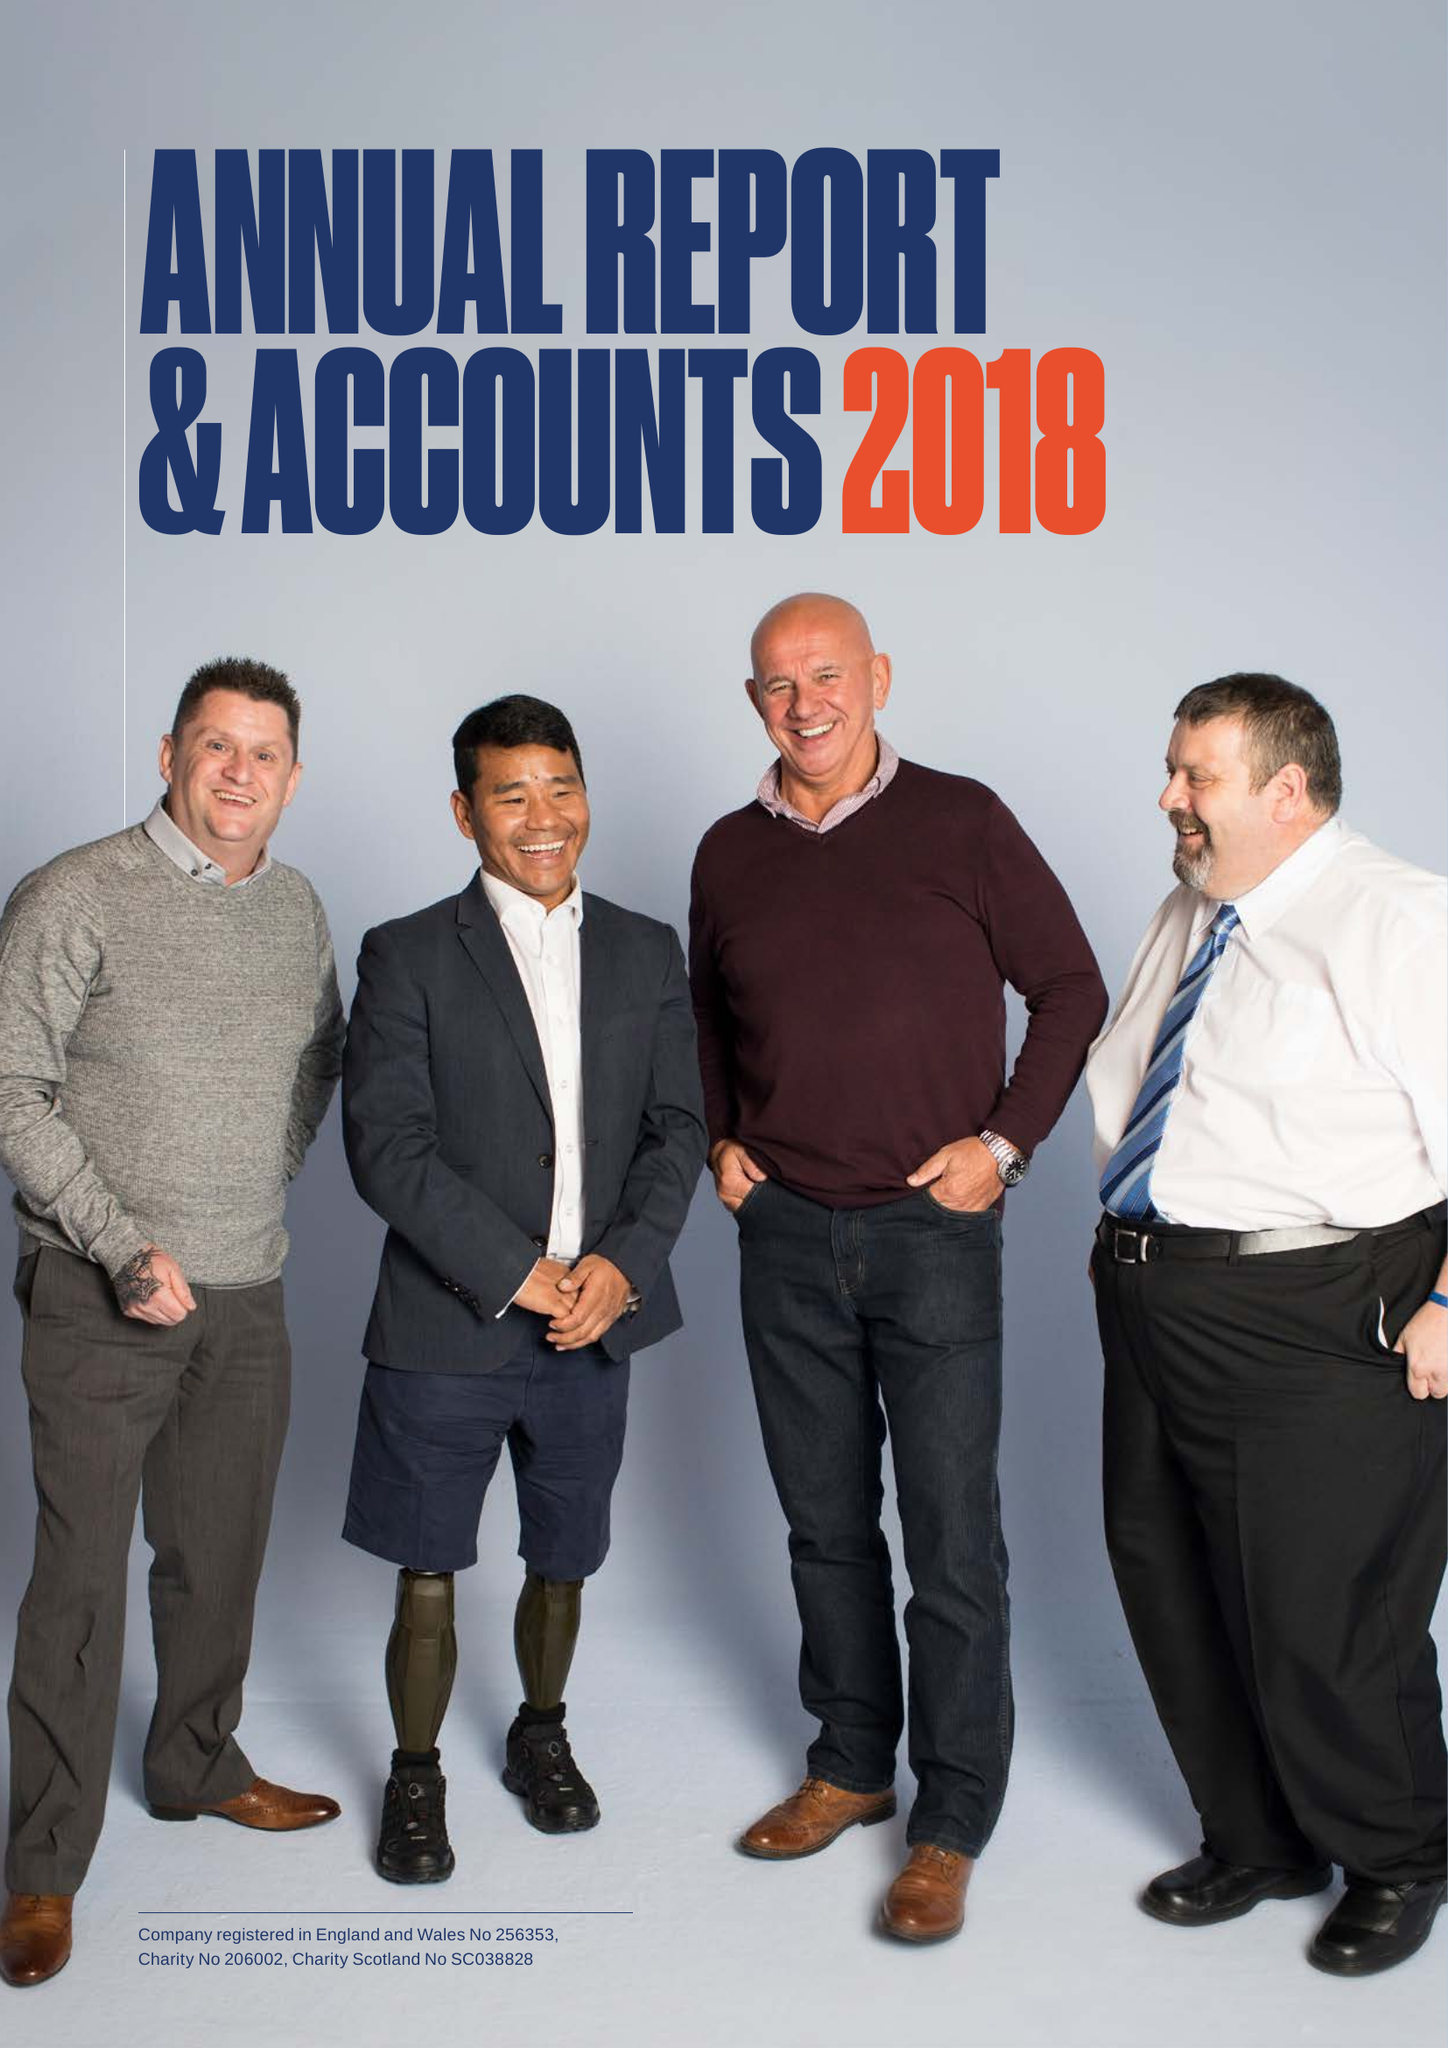What is the value for the charity_number?
Answer the question using a single word or phrase. 206002 